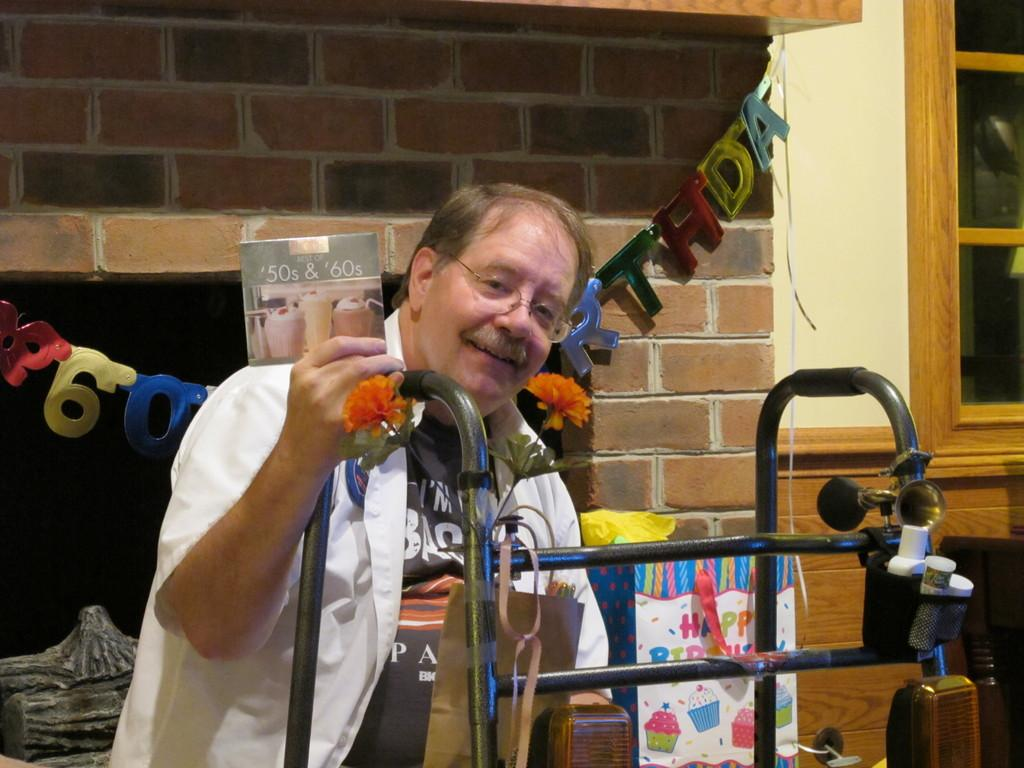Who is present in the image? There is a man in the image. What is the man doing in the image? The man is smiling in the image. What is the man holding in the image? The man is holding a card in his hands. What can be seen on the wall in the background of the image? There is a decoration hanging on the wall in the background. What architectural feature is visible in the background of the image? There is a window in the background. What type of objects can be seen in the background of the image? There are cloth bags and containers in the background. What type of waves can be seen crashing against the shore in the image? There are no waves or shore visible in the image; it features a man holding a card and a background with cloth bags and containers. 